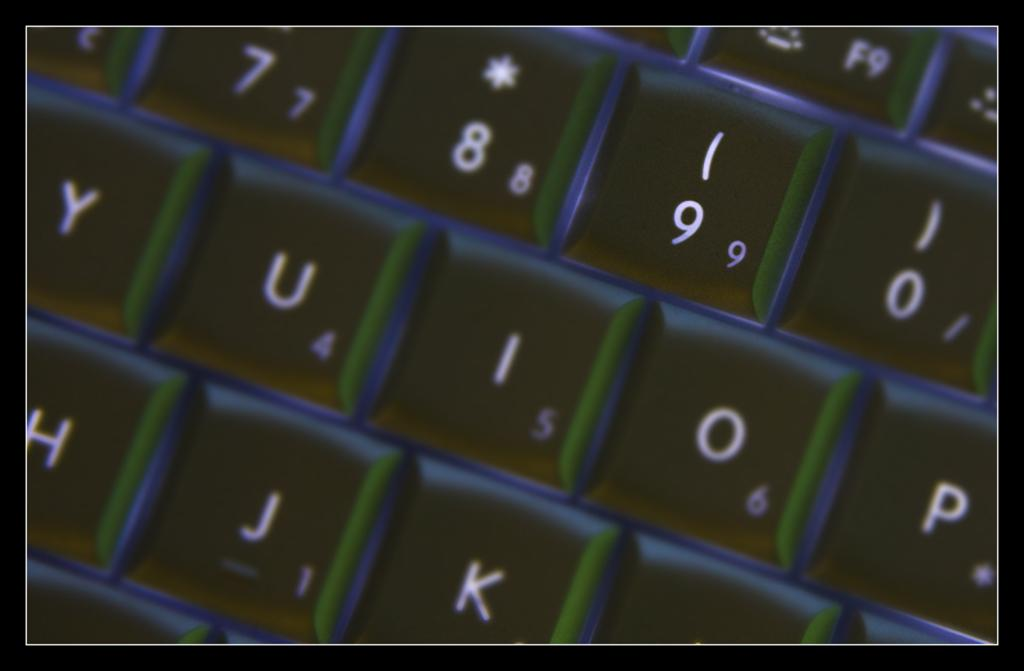Provide a one-sentence caption for the provided image. An up close look at a keyboard; the close up view is off the 7,8,9,0 and many letter keys. 